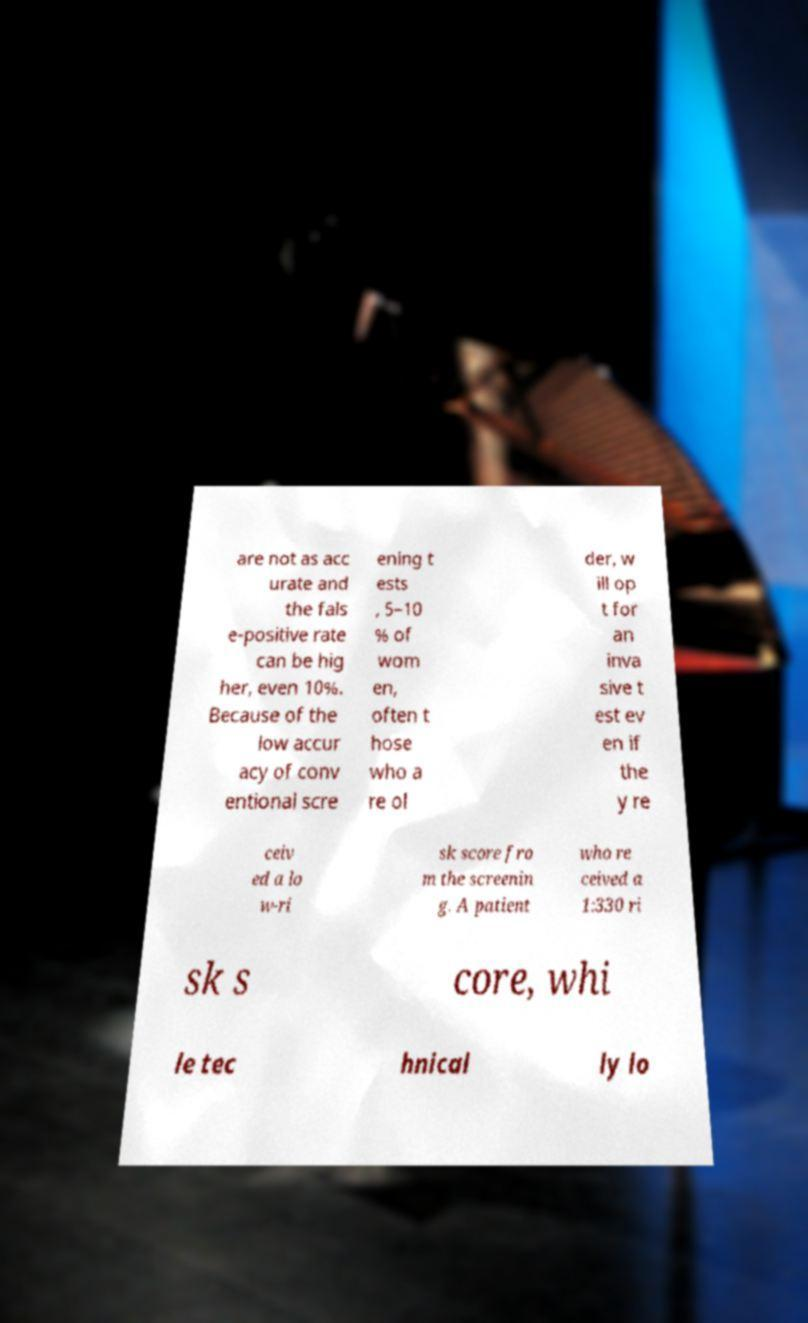Could you extract and type out the text from this image? are not as acc urate and the fals e-positive rate can be hig her, even 10%. Because of the low accur acy of conv entional scre ening t ests , 5–10 % of wom en, often t hose who a re ol der, w ill op t for an inva sive t est ev en if the y re ceiv ed a lo w-ri sk score fro m the screenin g. A patient who re ceived a 1:330 ri sk s core, whi le tec hnical ly lo 